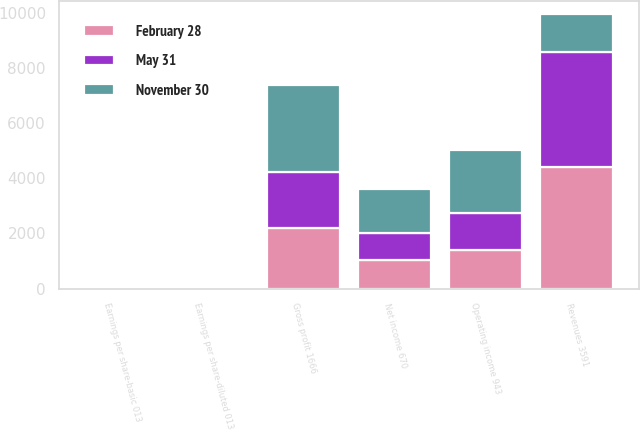Convert chart. <chart><loc_0><loc_0><loc_500><loc_500><stacked_bar_chart><ecel><fcel>Revenues 3591<fcel>Gross profit 1666<fcel>Operating income 943<fcel>Net income 670<fcel>Earnings per share-basic 013<fcel>Earnings per share-diluted 013<nl><fcel>May 31<fcel>4163<fcel>2024<fcel>1357<fcel>967<fcel>0.19<fcel>0.18<nl><fcel>February 28<fcel>4414<fcel>2197<fcel>1394<fcel>1033<fcel>0.2<fcel>0.2<nl><fcel>November 30<fcel>1357<fcel>3143<fcel>2281<fcel>1604<fcel>0.31<fcel>0.31<nl></chart> 